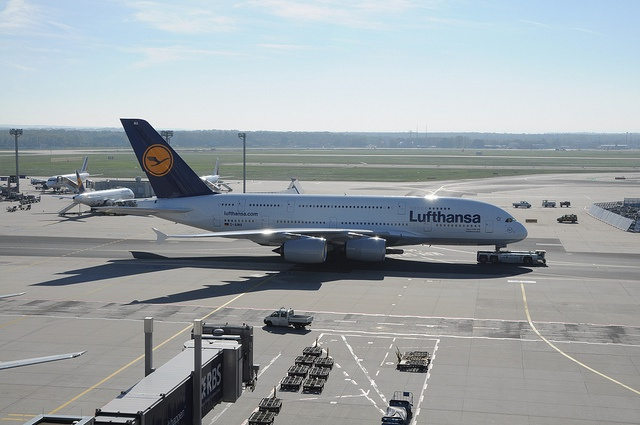Describe the objects in this image and their specific colors. I can see airplane in lightblue, gray, black, and darkgray tones, truck in lightblue, black, gray, and darkblue tones, airplane in lightblue, darkgray, gray, and lightgray tones, airplane in lightblue, gray, darkgray, and black tones, and truck in lightblue, gray, black, darkgray, and darkblue tones in this image. 